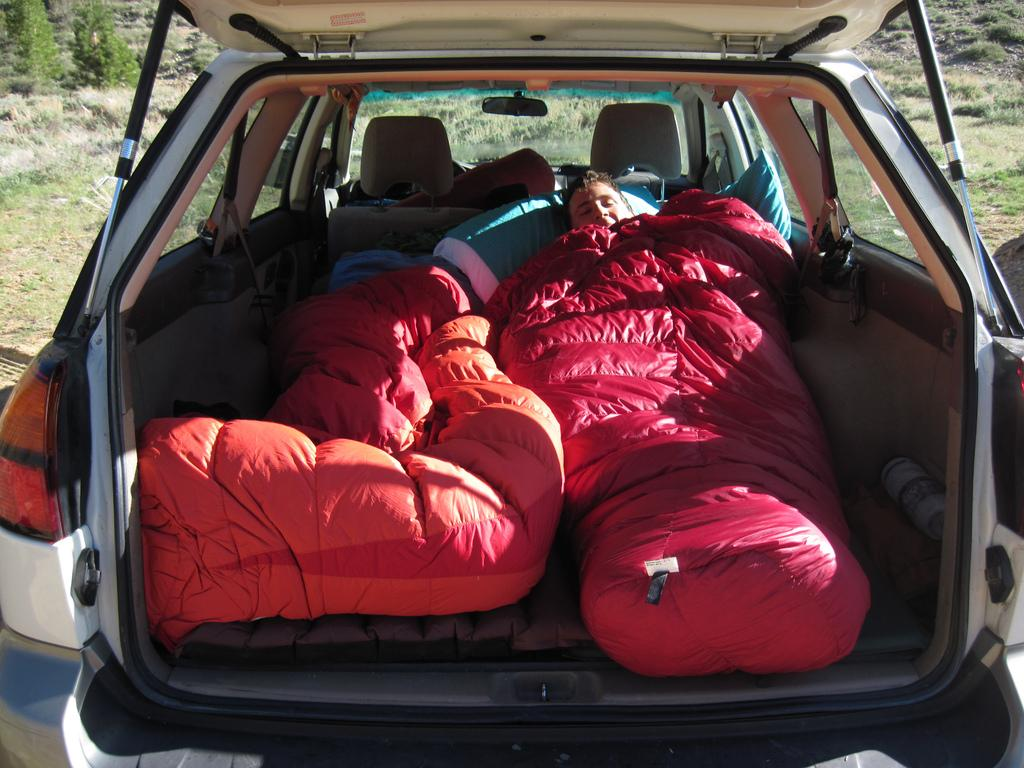What is the person in the image doing? There is a person lying in a car in the image. What can be seen in the background of the image? There are plants and grass in the background of the image. What type of veil is covering the person's face in the image? There is no veil present in the image; the person is lying in a car with no visible coverings on their face. 